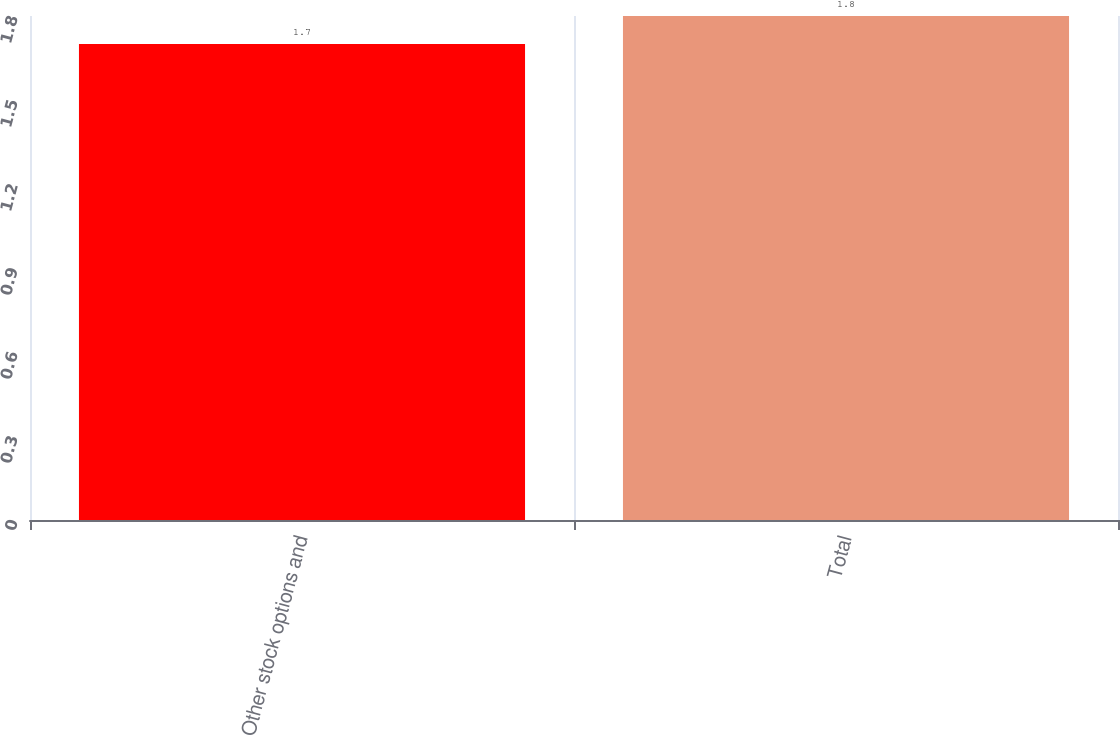Convert chart to OTSL. <chart><loc_0><loc_0><loc_500><loc_500><bar_chart><fcel>Other stock options and<fcel>Total<nl><fcel>1.7<fcel>1.8<nl></chart> 